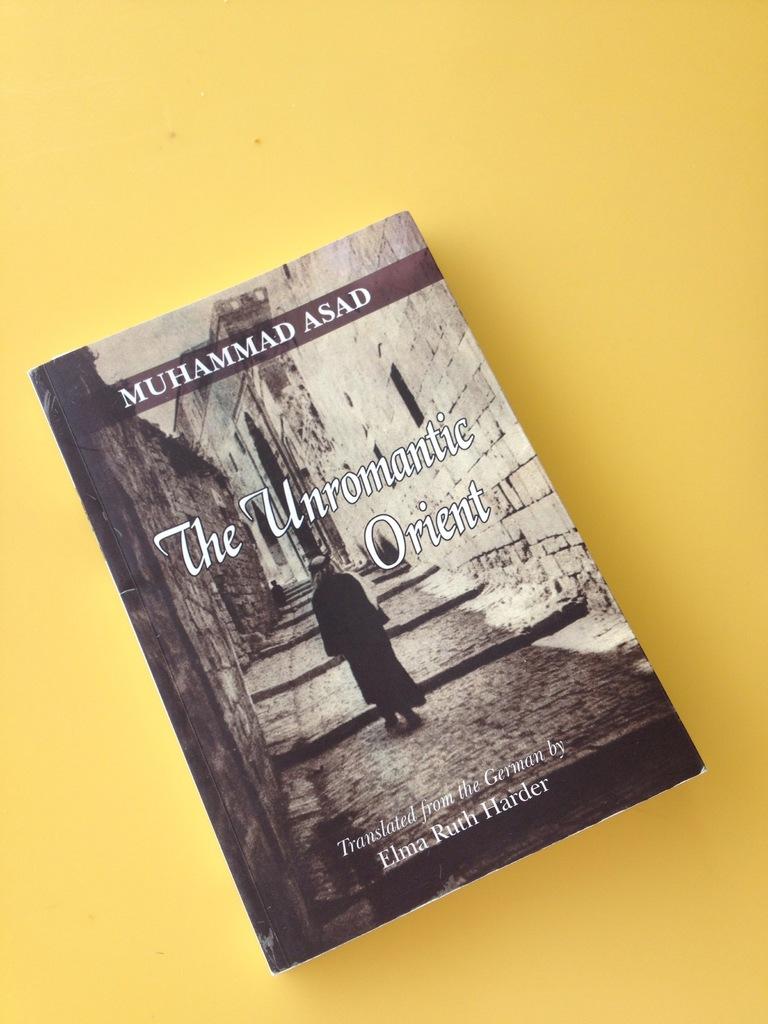Who is the author of this book?
Keep it short and to the point. Muhammad asad. 